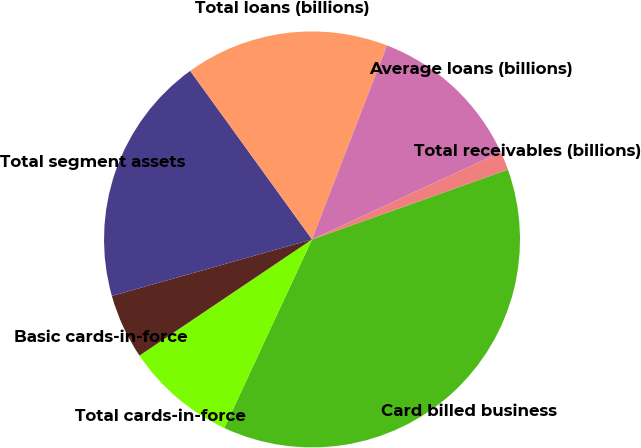Convert chart. <chart><loc_0><loc_0><loc_500><loc_500><pie_chart><fcel>Card billed business<fcel>Total cards-in-force<fcel>Basic cards-in-force<fcel>Total segment assets<fcel>Total loans (billions)<fcel>Average loans (billions)<fcel>Total receivables (billions)<nl><fcel>37.38%<fcel>8.64%<fcel>5.05%<fcel>19.42%<fcel>15.83%<fcel>12.23%<fcel>1.45%<nl></chart> 